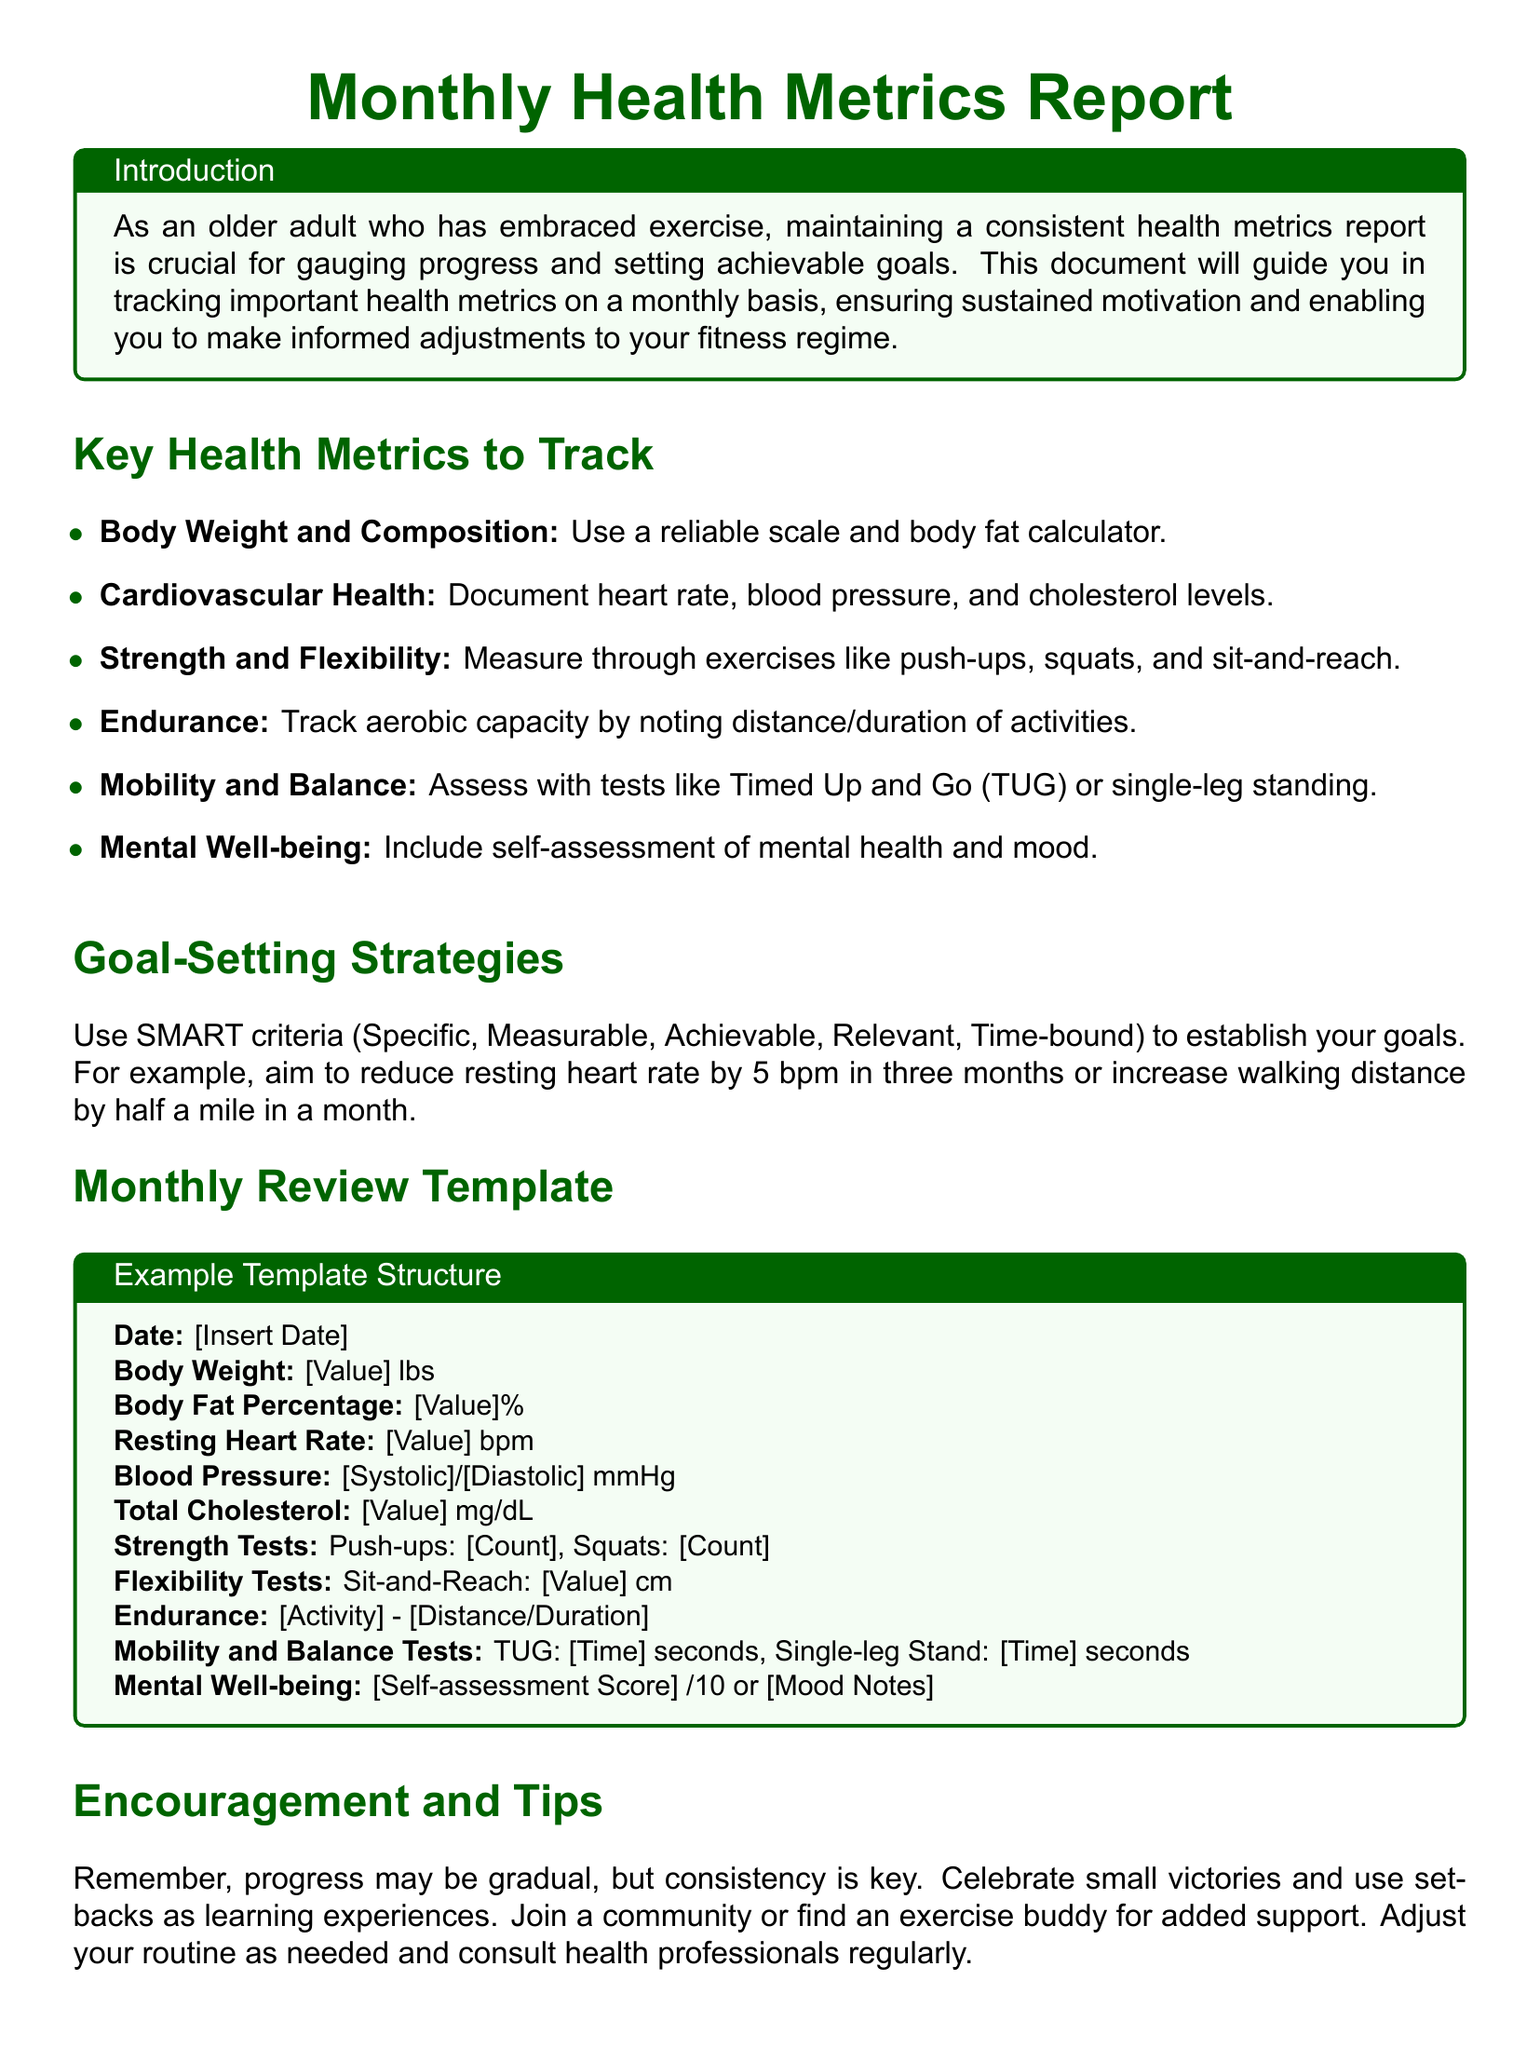What are the key health metrics to track? The document lists various key health metrics such as Body Weight, Cardiovascular Health, Strength and Flexibility, Endurance, Mobility and Balance, and Mental Well-being.
Answer: Body Weight and Composition, Cardiovascular Health, Strength and Flexibility, Endurance, Mobility and Balance, Mental Well-being What does SMART stand for in goal-setting? SMART is an acronym used to establish effective goals; the document does not define it, but it implies that the goals should be Specific, Measurable, Achievable, Relevant, and Time-bound.
Answer: Specific, Measurable, Achievable, Relevant, Time-bound What is the total cholesterol measurement unit mentioned? The document states that total cholesterol is measured in milligrams per deciliter (mg/dL).
Answer: mg/dL What is a suggested mental well-being self-assessment score range? The document mentions a self-assessment score out of 10 for evaluating mental well-being.
Answer: /10 What is a recommended time frame for reducing resting heart rate? The document suggests aiming to reduce resting heart rate within a specified period, stating a goal may be to reduce it by 5 bpm in three months.
Answer: three months How should the body weight be recorded? The document suggests using a reliable scale to document body weight.
Answer: reliable scale What are the names of two strength tests mentioned? The document includes push-ups and squats as examples of strength tests to be measured.
Answer: Push-ups, Squats What is a positive action to take in case of setbacks? The document encourages users to use setbacks as learning experiences.
Answer: learning experiences What type of community activity is encouraged for support? The document suggests joining a community or finding an exercise buddy for added support.
Answer: community or exercise buddy 